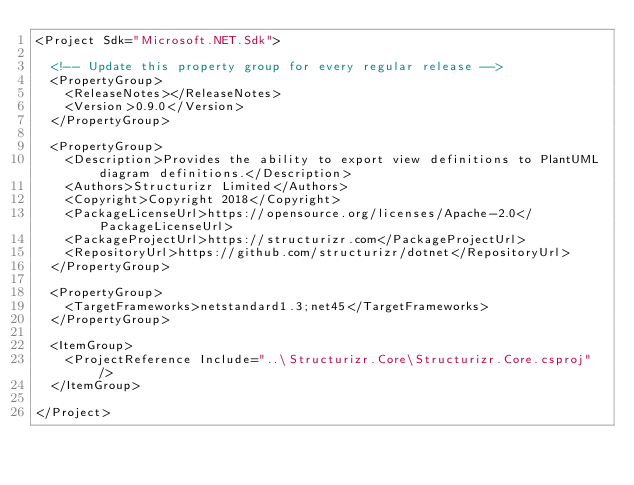Convert code to text. <code><loc_0><loc_0><loc_500><loc_500><_XML_><Project Sdk="Microsoft.NET.Sdk">

  <!-- Update this property group for every regular release -->
  <PropertyGroup>
    <ReleaseNotes></ReleaseNotes>
    <Version>0.9.0</Version>
  </PropertyGroup>

  <PropertyGroup>
    <Description>Provides the ability to export view definitions to PlantUML diagram definitions.</Description>
    <Authors>Structurizr Limited</Authors>
    <Copyright>Copyright 2018</Copyright>
    <PackageLicenseUrl>https://opensource.org/licenses/Apache-2.0</PackageLicenseUrl>
    <PackageProjectUrl>https://structurizr.com</PackageProjectUrl>
    <RepositoryUrl>https://github.com/structurizr/dotnet</RepositoryUrl>
  </PropertyGroup>

  <PropertyGroup>
    <TargetFrameworks>netstandard1.3;net45</TargetFrameworks>
  </PropertyGroup>

  <ItemGroup>
    <ProjectReference Include="..\Structurizr.Core\Structurizr.Core.csproj" />
  </ItemGroup>

</Project></code> 